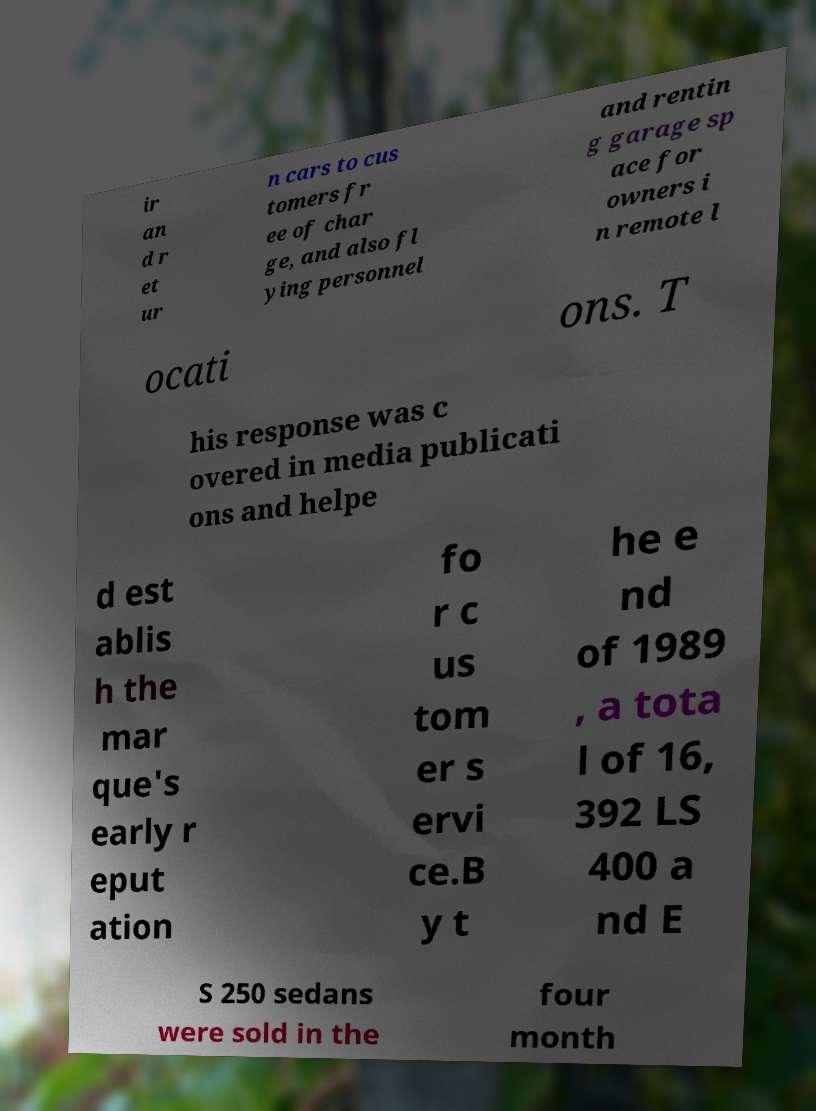I need the written content from this picture converted into text. Can you do that? ir an d r et ur n cars to cus tomers fr ee of char ge, and also fl ying personnel and rentin g garage sp ace for owners i n remote l ocati ons. T his response was c overed in media publicati ons and helpe d est ablis h the mar que's early r eput ation fo r c us tom er s ervi ce.B y t he e nd of 1989 , a tota l of 16, 392 LS 400 a nd E S 250 sedans were sold in the four month 